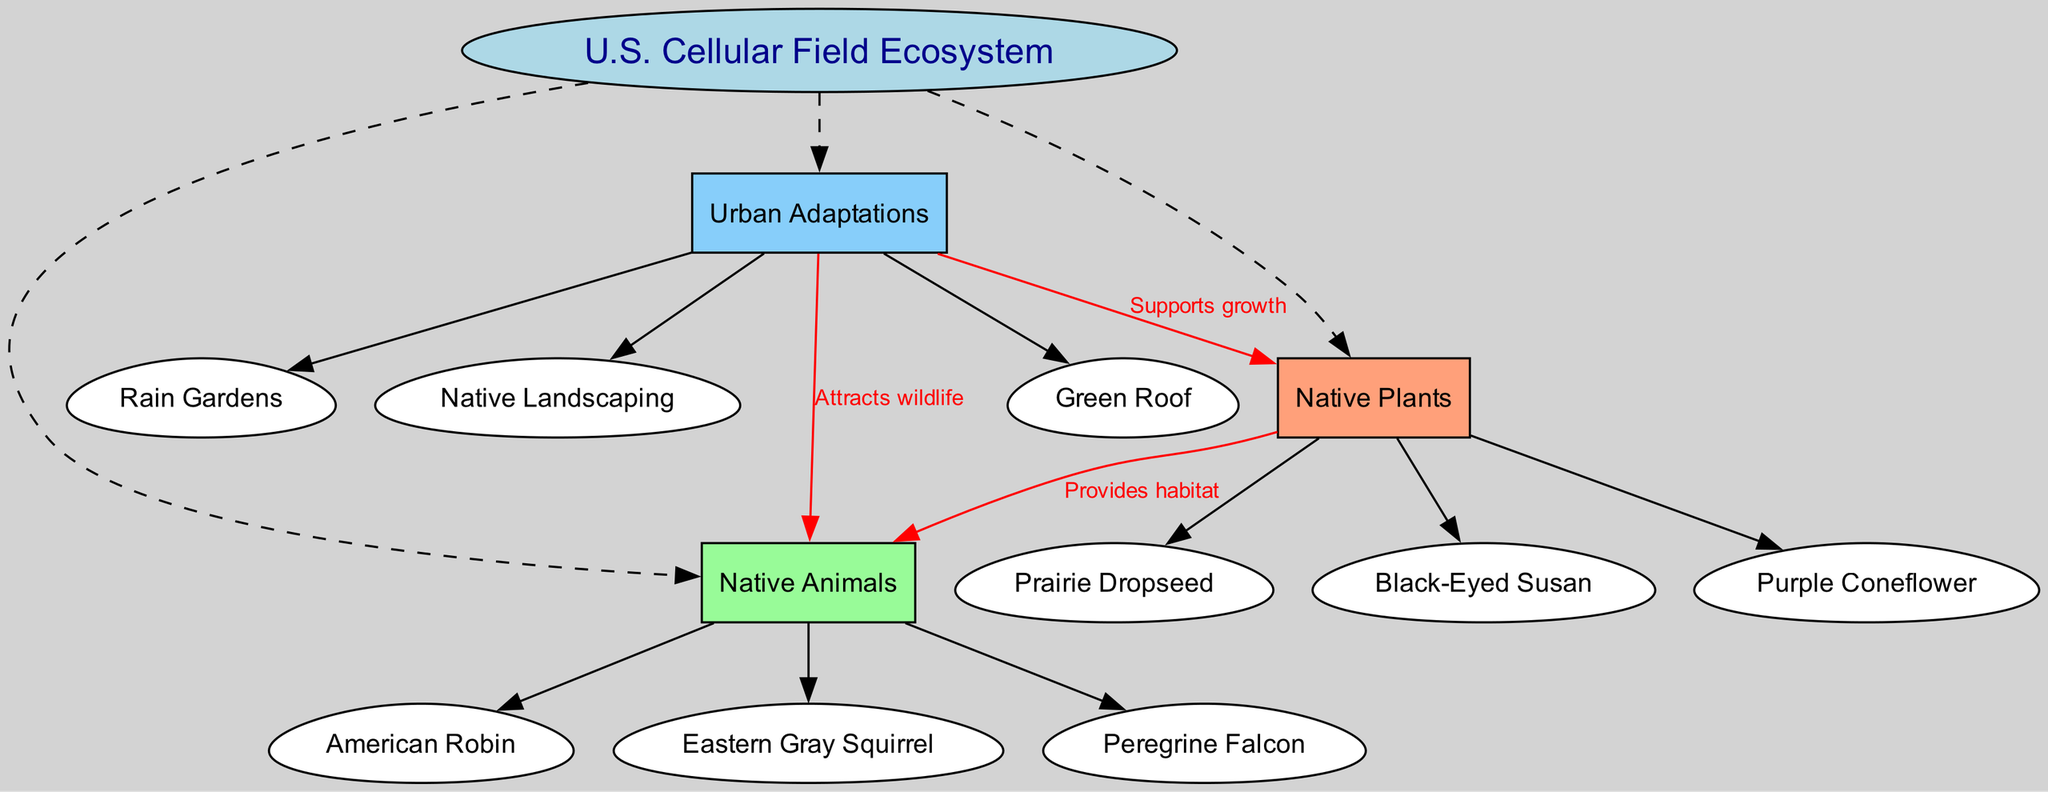What is the central topic of the diagram? The central topic is prominently displayed in the center of the diagram, labeled as "U.S. Cellular Field Ecosystem."
Answer: U.S. Cellular Field Ecosystem How many native plants are listed? There are three native plants explicitly listed under the "Native Plants" category in the diagram: Prairie Dropseed, Black-Eyed Susan, and Purple Coneflower.
Answer: 3 What animal is listed among native animals? The diagram shows "American Robin" as one of the native animals under the "Native Animals" category.
Answer: American Robin What is the relationship between native plants and native animals? The diagram indicates a directed relationship where native plants "Provides habitat" for native animals, signifying that the presence of these plants supports animal life.
Answer: Provides habitat Which urban adaptation supports the growth of native plants? The diagram indicates that "Rain Gardens" as one of the urban adaptations specifically listed under "Urban Adaptations," supports the growth of native plants, along with others.
Answer: Rain Gardens How many total main elements are in the diagram? There are three main elements shown in the diagram: Native Plants, Native Animals, and Urban Adaptations. This can be counted by identifying the main categories displayed under the central topic.
Answer: 3 What is one effect of urban adaptations on native animals? The diagram shows that urban adaptations such as "Native Landscaping" "Attracts wildlife," meaning they have a positive effect on native animals by bringing them to the area.
Answer: Attracts wildlife What are the colors used for native plants? The main node for native plants features the color '#FFA07A,' as indicated by the properties defined for that category in the diagram structure.
Answer: #FFA07A List one native animal noted for its urban adaptation. "Peregrine Falcon" is shown as one of the native animals that can thrive due to urban adaptations like green roofs, as indicated in the connection label in the diagram.
Answer: Peregrine Falcon 